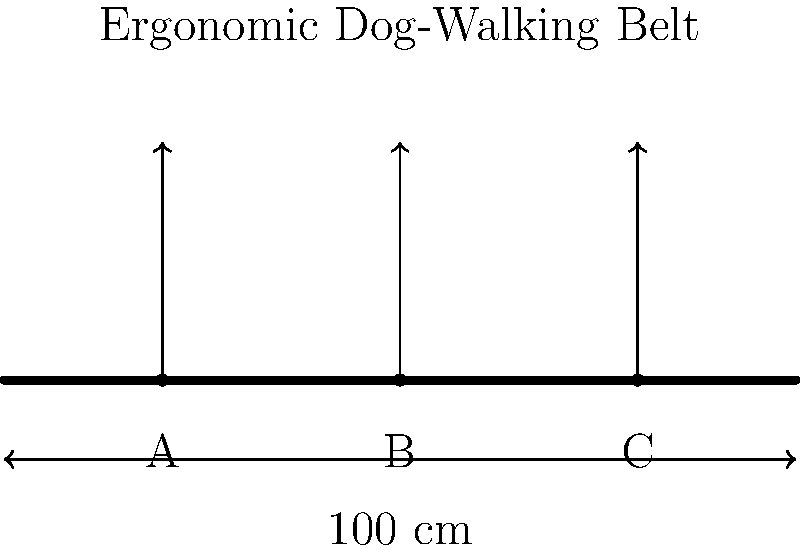In the technical drawing of an ergonomic dog-walking belt, three leash attachment points (A, B, and C) are shown. If the belt is 100 cm long and the attachment points are equally spaced, what is the distance between each attachment point? How does this spacing contribute to the belt's ergonomic design for a dog walker managing multiple dogs? To determine the distance between each attachment point and understand its ergonomic benefits, let's follow these steps:

1. Identify the given information:
   - The belt is 100 cm long
   - There are three attachment points (A, B, and C)
   - The attachment points are equally spaced

2. Calculate the number of spaces between attachment points:
   - Number of spaces = Number of attachment points - 1
   - Number of spaces = 3 - 1 = 2

3. Calculate the distance between each attachment point:
   - Distance = Total belt length / Number of spaces
   - Distance = 100 cm / 2 = 50 cm

4. Ergonomic benefits of this spacing:
   a) Even distribution of force: The equal spacing helps distribute the pull from multiple dogs more evenly across the walker's body, reducing strain on any one area.
   
   b) Flexibility in dog positioning: The walker can attach dogs to different points based on their size or behavior, allowing for better control and balance.
   
   c) Reduced tangling: The spacing provides enough room between leashes to minimize the risk of tangling, especially when walking multiple dogs.
   
   d) Adaptability: The walker can use one, two, or all three attachment points depending on the number of dogs, making the belt versatile for various walking scenarios.
   
   e) Improved posture: The even distribution of attachment points encourages the walker to maintain a more balanced and ergonomic posture while managing multiple dogs.

5. The 50 cm spacing strikes a balance between providing enough separation for the benefits mentioned above while keeping the attachment points within a comfortable reach for the dog walker.
Answer: 50 cm; even force distribution, flexibility, reduced tangling, adaptability, improved posture 